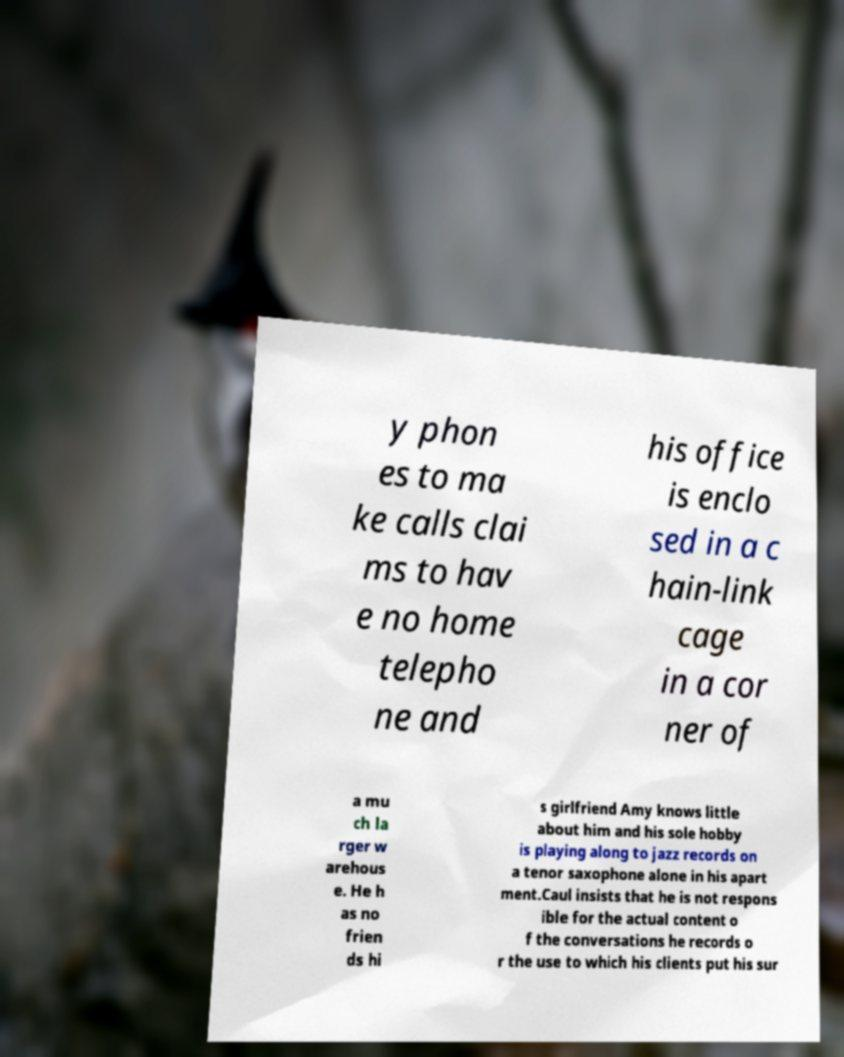For documentation purposes, I need the text within this image transcribed. Could you provide that? y phon es to ma ke calls clai ms to hav e no home telepho ne and his office is enclo sed in a c hain-link cage in a cor ner of a mu ch la rger w arehous e. He h as no frien ds hi s girlfriend Amy knows little about him and his sole hobby is playing along to jazz records on a tenor saxophone alone in his apart ment.Caul insists that he is not respons ible for the actual content o f the conversations he records o r the use to which his clients put his sur 